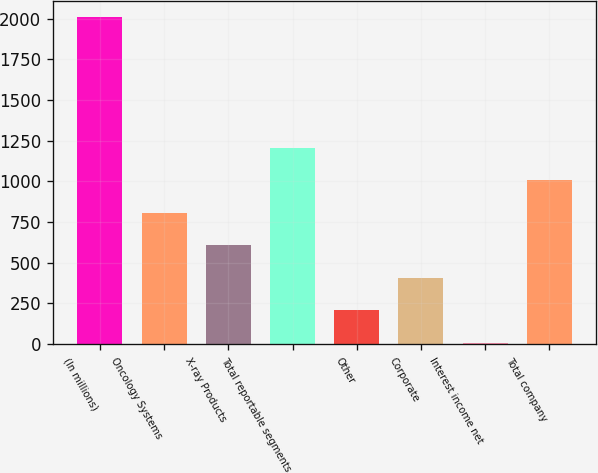Convert chart to OTSL. <chart><loc_0><loc_0><loc_500><loc_500><bar_chart><fcel>(In millions)<fcel>Oncology Systems<fcel>X-ray Products<fcel>Total reportable segments<fcel>Other<fcel>Corporate<fcel>Interest income net<fcel>Total company<nl><fcel>2007<fcel>807.6<fcel>607.7<fcel>1207.4<fcel>207.9<fcel>407.8<fcel>8<fcel>1007.5<nl></chart> 